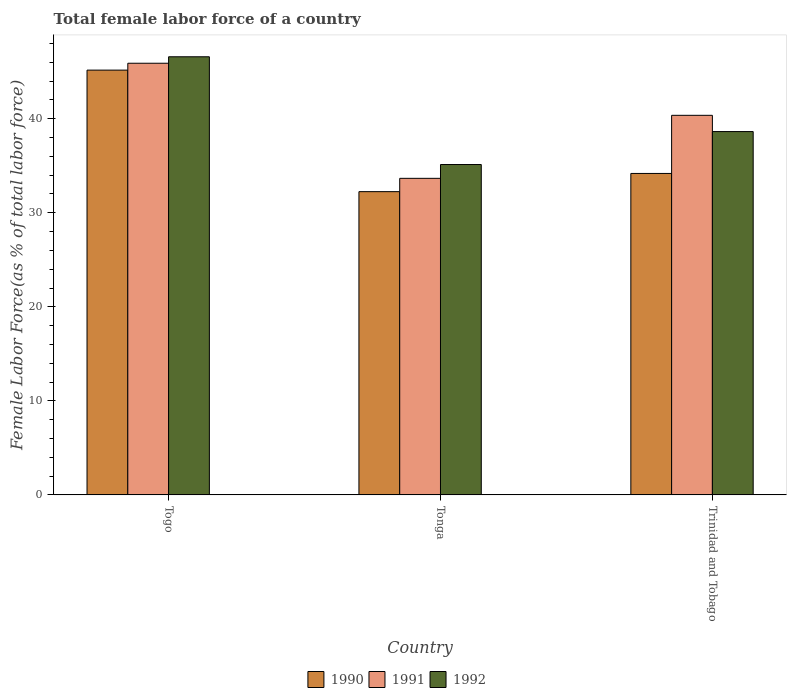Are the number of bars per tick equal to the number of legend labels?
Offer a very short reply. Yes. Are the number of bars on each tick of the X-axis equal?
Ensure brevity in your answer.  Yes. How many bars are there on the 2nd tick from the left?
Offer a very short reply. 3. How many bars are there on the 3rd tick from the right?
Your response must be concise. 3. What is the label of the 3rd group of bars from the left?
Make the answer very short. Trinidad and Tobago. In how many cases, is the number of bars for a given country not equal to the number of legend labels?
Provide a short and direct response. 0. What is the percentage of female labor force in 1992 in Trinidad and Tobago?
Keep it short and to the point. 38.64. Across all countries, what is the maximum percentage of female labor force in 1990?
Your answer should be very brief. 45.17. Across all countries, what is the minimum percentage of female labor force in 1990?
Keep it short and to the point. 32.25. In which country was the percentage of female labor force in 1992 maximum?
Your answer should be compact. Togo. In which country was the percentage of female labor force in 1990 minimum?
Make the answer very short. Tonga. What is the total percentage of female labor force in 1991 in the graph?
Ensure brevity in your answer.  119.93. What is the difference between the percentage of female labor force in 1991 in Togo and that in Tonga?
Ensure brevity in your answer.  12.24. What is the difference between the percentage of female labor force in 1990 in Tonga and the percentage of female labor force in 1992 in Trinidad and Tobago?
Keep it short and to the point. -6.39. What is the average percentage of female labor force in 1991 per country?
Your response must be concise. 39.98. What is the difference between the percentage of female labor force of/in 1991 and percentage of female labor force of/in 1992 in Tonga?
Give a very brief answer. -1.47. In how many countries, is the percentage of female labor force in 1990 greater than 38 %?
Your answer should be very brief. 1. What is the ratio of the percentage of female labor force in 1990 in Togo to that in Trinidad and Tobago?
Provide a succinct answer. 1.32. Is the percentage of female labor force in 1992 in Togo less than that in Trinidad and Tobago?
Provide a short and direct response. No. What is the difference between the highest and the second highest percentage of female labor force in 1990?
Your answer should be compact. -1.94. What is the difference between the highest and the lowest percentage of female labor force in 1990?
Give a very brief answer. 12.92. In how many countries, is the percentage of female labor force in 1991 greater than the average percentage of female labor force in 1991 taken over all countries?
Provide a succinct answer. 2. Is the sum of the percentage of female labor force in 1991 in Togo and Trinidad and Tobago greater than the maximum percentage of female labor force in 1992 across all countries?
Your response must be concise. Yes. Is it the case that in every country, the sum of the percentage of female labor force in 1992 and percentage of female labor force in 1990 is greater than the percentage of female labor force in 1991?
Keep it short and to the point. Yes. Are all the bars in the graph horizontal?
Provide a short and direct response. No. How many countries are there in the graph?
Provide a short and direct response. 3. What is the difference between two consecutive major ticks on the Y-axis?
Provide a short and direct response. 10. Are the values on the major ticks of Y-axis written in scientific E-notation?
Make the answer very short. No. Does the graph contain any zero values?
Ensure brevity in your answer.  No. How many legend labels are there?
Your answer should be very brief. 3. How are the legend labels stacked?
Make the answer very short. Horizontal. What is the title of the graph?
Offer a terse response. Total female labor force of a country. What is the label or title of the Y-axis?
Your answer should be very brief. Female Labor Force(as % of total labor force). What is the Female Labor Force(as % of total labor force) of 1990 in Togo?
Make the answer very short. 45.17. What is the Female Labor Force(as % of total labor force) in 1991 in Togo?
Make the answer very short. 45.9. What is the Female Labor Force(as % of total labor force) in 1992 in Togo?
Ensure brevity in your answer.  46.59. What is the Female Labor Force(as % of total labor force) in 1990 in Tonga?
Your answer should be compact. 32.25. What is the Female Labor Force(as % of total labor force) of 1991 in Tonga?
Your response must be concise. 33.66. What is the Female Labor Force(as % of total labor force) of 1992 in Tonga?
Provide a short and direct response. 35.13. What is the Female Labor Force(as % of total labor force) of 1990 in Trinidad and Tobago?
Your answer should be compact. 34.18. What is the Female Labor Force(as % of total labor force) of 1991 in Trinidad and Tobago?
Your answer should be very brief. 40.37. What is the Female Labor Force(as % of total labor force) in 1992 in Trinidad and Tobago?
Your response must be concise. 38.64. Across all countries, what is the maximum Female Labor Force(as % of total labor force) of 1990?
Make the answer very short. 45.17. Across all countries, what is the maximum Female Labor Force(as % of total labor force) of 1991?
Keep it short and to the point. 45.9. Across all countries, what is the maximum Female Labor Force(as % of total labor force) of 1992?
Offer a very short reply. 46.59. Across all countries, what is the minimum Female Labor Force(as % of total labor force) of 1990?
Your answer should be compact. 32.25. Across all countries, what is the minimum Female Labor Force(as % of total labor force) of 1991?
Offer a very short reply. 33.66. Across all countries, what is the minimum Female Labor Force(as % of total labor force) in 1992?
Offer a terse response. 35.13. What is the total Female Labor Force(as % of total labor force) of 1990 in the graph?
Give a very brief answer. 111.61. What is the total Female Labor Force(as % of total labor force) in 1991 in the graph?
Offer a very short reply. 119.93. What is the total Female Labor Force(as % of total labor force) in 1992 in the graph?
Ensure brevity in your answer.  120.36. What is the difference between the Female Labor Force(as % of total labor force) of 1990 in Togo and that in Tonga?
Your answer should be compact. 12.92. What is the difference between the Female Labor Force(as % of total labor force) of 1991 in Togo and that in Tonga?
Ensure brevity in your answer.  12.24. What is the difference between the Female Labor Force(as % of total labor force) in 1992 in Togo and that in Tonga?
Your answer should be very brief. 11.46. What is the difference between the Female Labor Force(as % of total labor force) of 1990 in Togo and that in Trinidad and Tobago?
Ensure brevity in your answer.  10.99. What is the difference between the Female Labor Force(as % of total labor force) in 1991 in Togo and that in Trinidad and Tobago?
Provide a succinct answer. 5.54. What is the difference between the Female Labor Force(as % of total labor force) of 1992 in Togo and that in Trinidad and Tobago?
Provide a short and direct response. 7.95. What is the difference between the Female Labor Force(as % of total labor force) of 1990 in Tonga and that in Trinidad and Tobago?
Offer a terse response. -1.94. What is the difference between the Female Labor Force(as % of total labor force) of 1991 in Tonga and that in Trinidad and Tobago?
Offer a very short reply. -6.7. What is the difference between the Female Labor Force(as % of total labor force) of 1992 in Tonga and that in Trinidad and Tobago?
Your answer should be very brief. -3.5. What is the difference between the Female Labor Force(as % of total labor force) of 1990 in Togo and the Female Labor Force(as % of total labor force) of 1991 in Tonga?
Offer a terse response. 11.51. What is the difference between the Female Labor Force(as % of total labor force) of 1990 in Togo and the Female Labor Force(as % of total labor force) of 1992 in Tonga?
Give a very brief answer. 10.04. What is the difference between the Female Labor Force(as % of total labor force) in 1991 in Togo and the Female Labor Force(as % of total labor force) in 1992 in Tonga?
Your answer should be very brief. 10.77. What is the difference between the Female Labor Force(as % of total labor force) of 1990 in Togo and the Female Labor Force(as % of total labor force) of 1991 in Trinidad and Tobago?
Offer a very short reply. 4.81. What is the difference between the Female Labor Force(as % of total labor force) of 1990 in Togo and the Female Labor Force(as % of total labor force) of 1992 in Trinidad and Tobago?
Your response must be concise. 6.54. What is the difference between the Female Labor Force(as % of total labor force) in 1991 in Togo and the Female Labor Force(as % of total labor force) in 1992 in Trinidad and Tobago?
Make the answer very short. 7.27. What is the difference between the Female Labor Force(as % of total labor force) in 1990 in Tonga and the Female Labor Force(as % of total labor force) in 1991 in Trinidad and Tobago?
Offer a terse response. -8.12. What is the difference between the Female Labor Force(as % of total labor force) of 1990 in Tonga and the Female Labor Force(as % of total labor force) of 1992 in Trinidad and Tobago?
Your answer should be compact. -6.39. What is the difference between the Female Labor Force(as % of total labor force) in 1991 in Tonga and the Female Labor Force(as % of total labor force) in 1992 in Trinidad and Tobago?
Your answer should be very brief. -4.97. What is the average Female Labor Force(as % of total labor force) in 1990 per country?
Your response must be concise. 37.2. What is the average Female Labor Force(as % of total labor force) of 1991 per country?
Give a very brief answer. 39.98. What is the average Female Labor Force(as % of total labor force) of 1992 per country?
Provide a short and direct response. 40.12. What is the difference between the Female Labor Force(as % of total labor force) in 1990 and Female Labor Force(as % of total labor force) in 1991 in Togo?
Ensure brevity in your answer.  -0.73. What is the difference between the Female Labor Force(as % of total labor force) in 1990 and Female Labor Force(as % of total labor force) in 1992 in Togo?
Keep it short and to the point. -1.42. What is the difference between the Female Labor Force(as % of total labor force) of 1991 and Female Labor Force(as % of total labor force) of 1992 in Togo?
Keep it short and to the point. -0.69. What is the difference between the Female Labor Force(as % of total labor force) in 1990 and Female Labor Force(as % of total labor force) in 1991 in Tonga?
Keep it short and to the point. -1.41. What is the difference between the Female Labor Force(as % of total labor force) of 1990 and Female Labor Force(as % of total labor force) of 1992 in Tonga?
Give a very brief answer. -2.89. What is the difference between the Female Labor Force(as % of total labor force) in 1991 and Female Labor Force(as % of total labor force) in 1992 in Tonga?
Provide a succinct answer. -1.47. What is the difference between the Female Labor Force(as % of total labor force) in 1990 and Female Labor Force(as % of total labor force) in 1991 in Trinidad and Tobago?
Ensure brevity in your answer.  -6.18. What is the difference between the Female Labor Force(as % of total labor force) of 1990 and Female Labor Force(as % of total labor force) of 1992 in Trinidad and Tobago?
Offer a very short reply. -4.45. What is the difference between the Female Labor Force(as % of total labor force) in 1991 and Female Labor Force(as % of total labor force) in 1992 in Trinidad and Tobago?
Your answer should be very brief. 1.73. What is the ratio of the Female Labor Force(as % of total labor force) in 1990 in Togo to that in Tonga?
Provide a short and direct response. 1.4. What is the ratio of the Female Labor Force(as % of total labor force) of 1991 in Togo to that in Tonga?
Keep it short and to the point. 1.36. What is the ratio of the Female Labor Force(as % of total labor force) of 1992 in Togo to that in Tonga?
Keep it short and to the point. 1.33. What is the ratio of the Female Labor Force(as % of total labor force) in 1990 in Togo to that in Trinidad and Tobago?
Make the answer very short. 1.32. What is the ratio of the Female Labor Force(as % of total labor force) in 1991 in Togo to that in Trinidad and Tobago?
Offer a terse response. 1.14. What is the ratio of the Female Labor Force(as % of total labor force) of 1992 in Togo to that in Trinidad and Tobago?
Keep it short and to the point. 1.21. What is the ratio of the Female Labor Force(as % of total labor force) of 1990 in Tonga to that in Trinidad and Tobago?
Your response must be concise. 0.94. What is the ratio of the Female Labor Force(as % of total labor force) in 1991 in Tonga to that in Trinidad and Tobago?
Provide a succinct answer. 0.83. What is the ratio of the Female Labor Force(as % of total labor force) of 1992 in Tonga to that in Trinidad and Tobago?
Your response must be concise. 0.91. What is the difference between the highest and the second highest Female Labor Force(as % of total labor force) of 1990?
Your response must be concise. 10.99. What is the difference between the highest and the second highest Female Labor Force(as % of total labor force) in 1991?
Ensure brevity in your answer.  5.54. What is the difference between the highest and the second highest Female Labor Force(as % of total labor force) in 1992?
Your answer should be compact. 7.95. What is the difference between the highest and the lowest Female Labor Force(as % of total labor force) of 1990?
Provide a short and direct response. 12.92. What is the difference between the highest and the lowest Female Labor Force(as % of total labor force) in 1991?
Ensure brevity in your answer.  12.24. What is the difference between the highest and the lowest Female Labor Force(as % of total labor force) of 1992?
Provide a succinct answer. 11.46. 